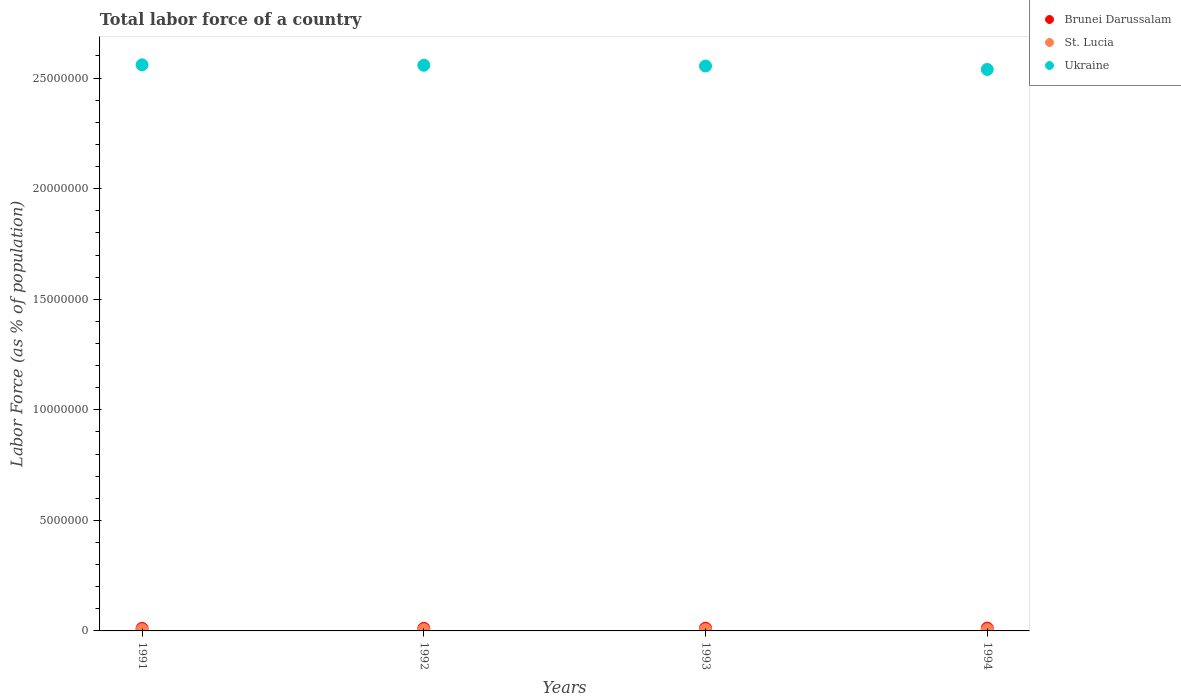What is the percentage of labor force in St. Lucia in 1991?
Your answer should be compact. 5.97e+04. Across all years, what is the maximum percentage of labor force in Brunei Darussalam?
Offer a very short reply. 1.27e+05. Across all years, what is the minimum percentage of labor force in Brunei Darussalam?
Offer a terse response. 1.14e+05. In which year was the percentage of labor force in Ukraine maximum?
Give a very brief answer. 1991. What is the total percentage of labor force in St. Lucia in the graph?
Provide a succinct answer. 2.46e+05. What is the difference between the percentage of labor force in St. Lucia in 1992 and that in 1994?
Offer a terse response. -2465. What is the difference between the percentage of labor force in Ukraine in 1991 and the percentage of labor force in Brunei Darussalam in 1992?
Your response must be concise. 2.55e+07. What is the average percentage of labor force in St. Lucia per year?
Make the answer very short. 6.14e+04. In the year 1992, what is the difference between the percentage of labor force in Brunei Darussalam and percentage of labor force in Ukraine?
Offer a terse response. -2.55e+07. What is the ratio of the percentage of labor force in St. Lucia in 1993 to that in 1994?
Your response must be concise. 0.98. Is the difference between the percentage of labor force in Brunei Darussalam in 1992 and 1994 greater than the difference between the percentage of labor force in Ukraine in 1992 and 1994?
Offer a terse response. No. What is the difference between the highest and the second highest percentage of labor force in Ukraine?
Keep it short and to the point. 1.99e+04. What is the difference between the highest and the lowest percentage of labor force in Brunei Darussalam?
Keep it short and to the point. 1.27e+04. In how many years, is the percentage of labor force in Ukraine greater than the average percentage of labor force in Ukraine taken over all years?
Offer a very short reply. 3. Is the sum of the percentage of labor force in Brunei Darussalam in 1991 and 1994 greater than the maximum percentage of labor force in St. Lucia across all years?
Your response must be concise. Yes. Is it the case that in every year, the sum of the percentage of labor force in Brunei Darussalam and percentage of labor force in Ukraine  is greater than the percentage of labor force in St. Lucia?
Keep it short and to the point. Yes. Is the percentage of labor force in St. Lucia strictly greater than the percentage of labor force in Ukraine over the years?
Offer a terse response. No. What is the difference between two consecutive major ticks on the Y-axis?
Provide a short and direct response. 5.00e+06. Are the values on the major ticks of Y-axis written in scientific E-notation?
Your response must be concise. No. Where does the legend appear in the graph?
Your response must be concise. Top right. How are the legend labels stacked?
Provide a short and direct response. Vertical. What is the title of the graph?
Your response must be concise. Total labor force of a country. What is the label or title of the X-axis?
Ensure brevity in your answer.  Years. What is the label or title of the Y-axis?
Provide a short and direct response. Labor Force (as % of population). What is the Labor Force (as % of population) of Brunei Darussalam in 1991?
Give a very brief answer. 1.14e+05. What is the Labor Force (as % of population) of St. Lucia in 1991?
Provide a succinct answer. 5.97e+04. What is the Labor Force (as % of population) in Ukraine in 1991?
Your answer should be compact. 2.56e+07. What is the Labor Force (as % of population) of Brunei Darussalam in 1992?
Your answer should be very brief. 1.18e+05. What is the Labor Force (as % of population) of St. Lucia in 1992?
Your answer should be very brief. 6.07e+04. What is the Labor Force (as % of population) in Ukraine in 1992?
Ensure brevity in your answer.  2.56e+07. What is the Labor Force (as % of population) of Brunei Darussalam in 1993?
Provide a succinct answer. 1.22e+05. What is the Labor Force (as % of population) in St. Lucia in 1993?
Your answer should be compact. 6.20e+04. What is the Labor Force (as % of population) of Ukraine in 1993?
Provide a succinct answer. 2.55e+07. What is the Labor Force (as % of population) of Brunei Darussalam in 1994?
Make the answer very short. 1.27e+05. What is the Labor Force (as % of population) in St. Lucia in 1994?
Your answer should be compact. 6.32e+04. What is the Labor Force (as % of population) of Ukraine in 1994?
Your response must be concise. 2.54e+07. Across all years, what is the maximum Labor Force (as % of population) of Brunei Darussalam?
Give a very brief answer. 1.27e+05. Across all years, what is the maximum Labor Force (as % of population) of St. Lucia?
Your answer should be very brief. 6.32e+04. Across all years, what is the maximum Labor Force (as % of population) of Ukraine?
Make the answer very short. 2.56e+07. Across all years, what is the minimum Labor Force (as % of population) in Brunei Darussalam?
Your response must be concise. 1.14e+05. Across all years, what is the minimum Labor Force (as % of population) of St. Lucia?
Give a very brief answer. 5.97e+04. Across all years, what is the minimum Labor Force (as % of population) in Ukraine?
Give a very brief answer. 2.54e+07. What is the total Labor Force (as % of population) of Brunei Darussalam in the graph?
Provide a short and direct response. 4.81e+05. What is the total Labor Force (as % of population) of St. Lucia in the graph?
Ensure brevity in your answer.  2.46e+05. What is the total Labor Force (as % of population) of Ukraine in the graph?
Keep it short and to the point. 1.02e+08. What is the difference between the Labor Force (as % of population) in Brunei Darussalam in 1991 and that in 1992?
Keep it short and to the point. -4124. What is the difference between the Labor Force (as % of population) in St. Lucia in 1991 and that in 1992?
Make the answer very short. -1066. What is the difference between the Labor Force (as % of population) in Ukraine in 1991 and that in 1992?
Give a very brief answer. 1.99e+04. What is the difference between the Labor Force (as % of population) in Brunei Darussalam in 1991 and that in 1993?
Give a very brief answer. -8436. What is the difference between the Labor Force (as % of population) in St. Lucia in 1991 and that in 1993?
Provide a succinct answer. -2295. What is the difference between the Labor Force (as % of population) of Ukraine in 1991 and that in 1993?
Offer a terse response. 5.41e+04. What is the difference between the Labor Force (as % of population) in Brunei Darussalam in 1991 and that in 1994?
Offer a very short reply. -1.27e+04. What is the difference between the Labor Force (as % of population) of St. Lucia in 1991 and that in 1994?
Your answer should be very brief. -3531. What is the difference between the Labor Force (as % of population) in Ukraine in 1991 and that in 1994?
Your response must be concise. 2.10e+05. What is the difference between the Labor Force (as % of population) of Brunei Darussalam in 1992 and that in 1993?
Ensure brevity in your answer.  -4312. What is the difference between the Labor Force (as % of population) of St. Lucia in 1992 and that in 1993?
Offer a terse response. -1229. What is the difference between the Labor Force (as % of population) in Ukraine in 1992 and that in 1993?
Offer a very short reply. 3.41e+04. What is the difference between the Labor Force (as % of population) in Brunei Darussalam in 1992 and that in 1994?
Keep it short and to the point. -8552. What is the difference between the Labor Force (as % of population) in St. Lucia in 1992 and that in 1994?
Ensure brevity in your answer.  -2465. What is the difference between the Labor Force (as % of population) in Ukraine in 1992 and that in 1994?
Give a very brief answer. 1.90e+05. What is the difference between the Labor Force (as % of population) in Brunei Darussalam in 1993 and that in 1994?
Provide a succinct answer. -4240. What is the difference between the Labor Force (as % of population) in St. Lucia in 1993 and that in 1994?
Provide a succinct answer. -1236. What is the difference between the Labor Force (as % of population) of Ukraine in 1993 and that in 1994?
Keep it short and to the point. 1.56e+05. What is the difference between the Labor Force (as % of population) of Brunei Darussalam in 1991 and the Labor Force (as % of population) of St. Lucia in 1992?
Keep it short and to the point. 5.32e+04. What is the difference between the Labor Force (as % of population) in Brunei Darussalam in 1991 and the Labor Force (as % of population) in Ukraine in 1992?
Offer a terse response. -2.55e+07. What is the difference between the Labor Force (as % of population) of St. Lucia in 1991 and the Labor Force (as % of population) of Ukraine in 1992?
Your response must be concise. -2.55e+07. What is the difference between the Labor Force (as % of population) of Brunei Darussalam in 1991 and the Labor Force (as % of population) of St. Lucia in 1993?
Your answer should be very brief. 5.19e+04. What is the difference between the Labor Force (as % of population) in Brunei Darussalam in 1991 and the Labor Force (as % of population) in Ukraine in 1993?
Your answer should be compact. -2.54e+07. What is the difference between the Labor Force (as % of population) of St. Lucia in 1991 and the Labor Force (as % of population) of Ukraine in 1993?
Make the answer very short. -2.55e+07. What is the difference between the Labor Force (as % of population) in Brunei Darussalam in 1991 and the Labor Force (as % of population) in St. Lucia in 1994?
Keep it short and to the point. 5.07e+04. What is the difference between the Labor Force (as % of population) of Brunei Darussalam in 1991 and the Labor Force (as % of population) of Ukraine in 1994?
Make the answer very short. -2.53e+07. What is the difference between the Labor Force (as % of population) of St. Lucia in 1991 and the Labor Force (as % of population) of Ukraine in 1994?
Provide a succinct answer. -2.53e+07. What is the difference between the Labor Force (as % of population) of Brunei Darussalam in 1992 and the Labor Force (as % of population) of St. Lucia in 1993?
Your response must be concise. 5.61e+04. What is the difference between the Labor Force (as % of population) of Brunei Darussalam in 1992 and the Labor Force (as % of population) of Ukraine in 1993?
Make the answer very short. -2.54e+07. What is the difference between the Labor Force (as % of population) in St. Lucia in 1992 and the Labor Force (as % of population) in Ukraine in 1993?
Provide a succinct answer. -2.55e+07. What is the difference between the Labor Force (as % of population) of Brunei Darussalam in 1992 and the Labor Force (as % of population) of St. Lucia in 1994?
Your response must be concise. 5.48e+04. What is the difference between the Labor Force (as % of population) of Brunei Darussalam in 1992 and the Labor Force (as % of population) of Ukraine in 1994?
Keep it short and to the point. -2.53e+07. What is the difference between the Labor Force (as % of population) of St. Lucia in 1992 and the Labor Force (as % of population) of Ukraine in 1994?
Keep it short and to the point. -2.53e+07. What is the difference between the Labor Force (as % of population) of Brunei Darussalam in 1993 and the Labor Force (as % of population) of St. Lucia in 1994?
Provide a succinct answer. 5.91e+04. What is the difference between the Labor Force (as % of population) of Brunei Darussalam in 1993 and the Labor Force (as % of population) of Ukraine in 1994?
Make the answer very short. -2.53e+07. What is the difference between the Labor Force (as % of population) in St. Lucia in 1993 and the Labor Force (as % of population) in Ukraine in 1994?
Ensure brevity in your answer.  -2.53e+07. What is the average Labor Force (as % of population) in Brunei Darussalam per year?
Your response must be concise. 1.20e+05. What is the average Labor Force (as % of population) in St. Lucia per year?
Provide a short and direct response. 6.14e+04. What is the average Labor Force (as % of population) of Ukraine per year?
Make the answer very short. 2.55e+07. In the year 1991, what is the difference between the Labor Force (as % of population) in Brunei Darussalam and Labor Force (as % of population) in St. Lucia?
Your answer should be compact. 5.42e+04. In the year 1991, what is the difference between the Labor Force (as % of population) of Brunei Darussalam and Labor Force (as % of population) of Ukraine?
Your response must be concise. -2.55e+07. In the year 1991, what is the difference between the Labor Force (as % of population) in St. Lucia and Labor Force (as % of population) in Ukraine?
Make the answer very short. -2.55e+07. In the year 1992, what is the difference between the Labor Force (as % of population) of Brunei Darussalam and Labor Force (as % of population) of St. Lucia?
Provide a succinct answer. 5.73e+04. In the year 1992, what is the difference between the Labor Force (as % of population) of Brunei Darussalam and Labor Force (as % of population) of Ukraine?
Give a very brief answer. -2.55e+07. In the year 1992, what is the difference between the Labor Force (as % of population) of St. Lucia and Labor Force (as % of population) of Ukraine?
Your response must be concise. -2.55e+07. In the year 1993, what is the difference between the Labor Force (as % of population) in Brunei Darussalam and Labor Force (as % of population) in St. Lucia?
Give a very brief answer. 6.04e+04. In the year 1993, what is the difference between the Labor Force (as % of population) in Brunei Darussalam and Labor Force (as % of population) in Ukraine?
Your response must be concise. -2.54e+07. In the year 1993, what is the difference between the Labor Force (as % of population) of St. Lucia and Labor Force (as % of population) of Ukraine?
Your answer should be compact. -2.55e+07. In the year 1994, what is the difference between the Labor Force (as % of population) of Brunei Darussalam and Labor Force (as % of population) of St. Lucia?
Provide a succinct answer. 6.34e+04. In the year 1994, what is the difference between the Labor Force (as % of population) in Brunei Darussalam and Labor Force (as % of population) in Ukraine?
Your answer should be compact. -2.53e+07. In the year 1994, what is the difference between the Labor Force (as % of population) in St. Lucia and Labor Force (as % of population) in Ukraine?
Offer a terse response. -2.53e+07. What is the ratio of the Labor Force (as % of population) in Brunei Darussalam in 1991 to that in 1992?
Your answer should be very brief. 0.97. What is the ratio of the Labor Force (as % of population) in St. Lucia in 1991 to that in 1992?
Keep it short and to the point. 0.98. What is the ratio of the Labor Force (as % of population) of Ukraine in 1991 to that in 1992?
Offer a very short reply. 1. What is the ratio of the Labor Force (as % of population) of St. Lucia in 1991 to that in 1993?
Provide a succinct answer. 0.96. What is the ratio of the Labor Force (as % of population) of Brunei Darussalam in 1991 to that in 1994?
Give a very brief answer. 0.9. What is the ratio of the Labor Force (as % of population) in St. Lucia in 1991 to that in 1994?
Your answer should be very brief. 0.94. What is the ratio of the Labor Force (as % of population) of Ukraine in 1991 to that in 1994?
Your answer should be very brief. 1.01. What is the ratio of the Labor Force (as % of population) of Brunei Darussalam in 1992 to that in 1993?
Offer a very short reply. 0.96. What is the ratio of the Labor Force (as % of population) in St. Lucia in 1992 to that in 1993?
Provide a succinct answer. 0.98. What is the ratio of the Labor Force (as % of population) of Brunei Darussalam in 1992 to that in 1994?
Offer a very short reply. 0.93. What is the ratio of the Labor Force (as % of population) in St. Lucia in 1992 to that in 1994?
Ensure brevity in your answer.  0.96. What is the ratio of the Labor Force (as % of population) of Ukraine in 1992 to that in 1994?
Your response must be concise. 1.01. What is the ratio of the Labor Force (as % of population) of Brunei Darussalam in 1993 to that in 1994?
Your answer should be very brief. 0.97. What is the ratio of the Labor Force (as % of population) in St. Lucia in 1993 to that in 1994?
Make the answer very short. 0.98. What is the ratio of the Labor Force (as % of population) in Ukraine in 1993 to that in 1994?
Make the answer very short. 1.01. What is the difference between the highest and the second highest Labor Force (as % of population) in Brunei Darussalam?
Provide a short and direct response. 4240. What is the difference between the highest and the second highest Labor Force (as % of population) in St. Lucia?
Your answer should be very brief. 1236. What is the difference between the highest and the second highest Labor Force (as % of population) of Ukraine?
Your answer should be compact. 1.99e+04. What is the difference between the highest and the lowest Labor Force (as % of population) of Brunei Darussalam?
Offer a terse response. 1.27e+04. What is the difference between the highest and the lowest Labor Force (as % of population) of St. Lucia?
Make the answer very short. 3531. What is the difference between the highest and the lowest Labor Force (as % of population) of Ukraine?
Give a very brief answer. 2.10e+05. 